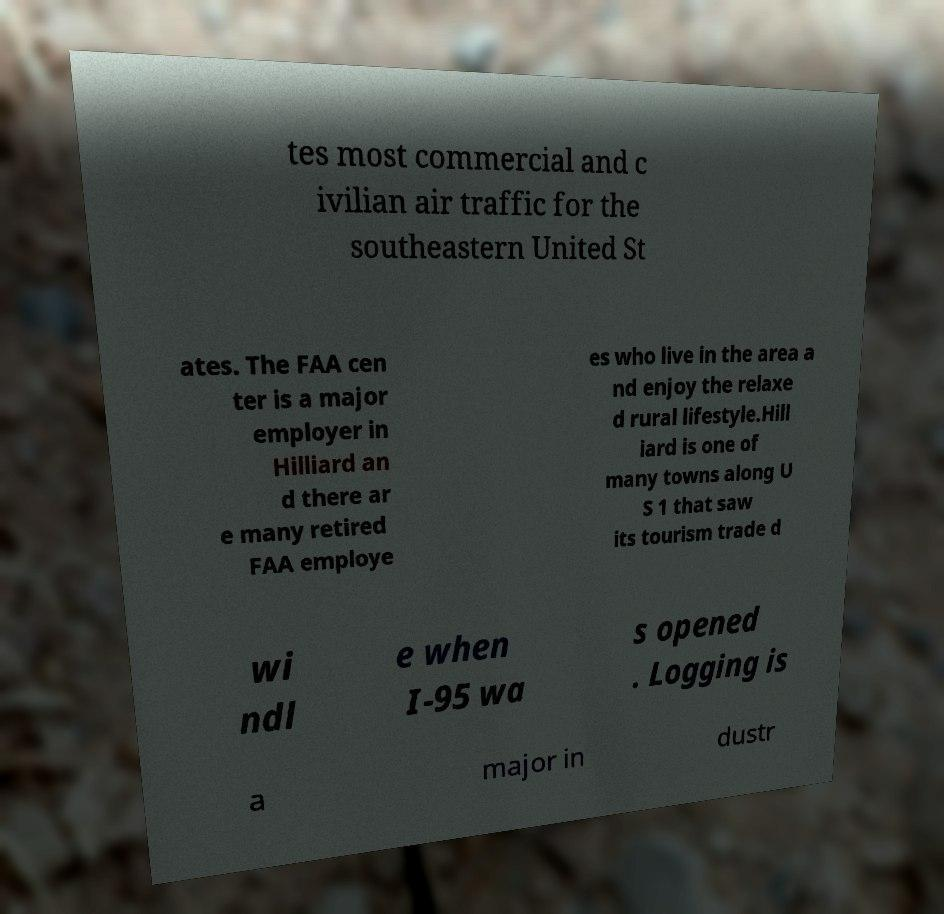Can you accurately transcribe the text from the provided image for me? tes most commercial and c ivilian air traffic for the southeastern United St ates. The FAA cen ter is a major employer in Hilliard an d there ar e many retired FAA employe es who live in the area a nd enjoy the relaxe d rural lifestyle.Hill iard is one of many towns along U S 1 that saw its tourism trade d wi ndl e when I-95 wa s opened . Logging is a major in dustr 